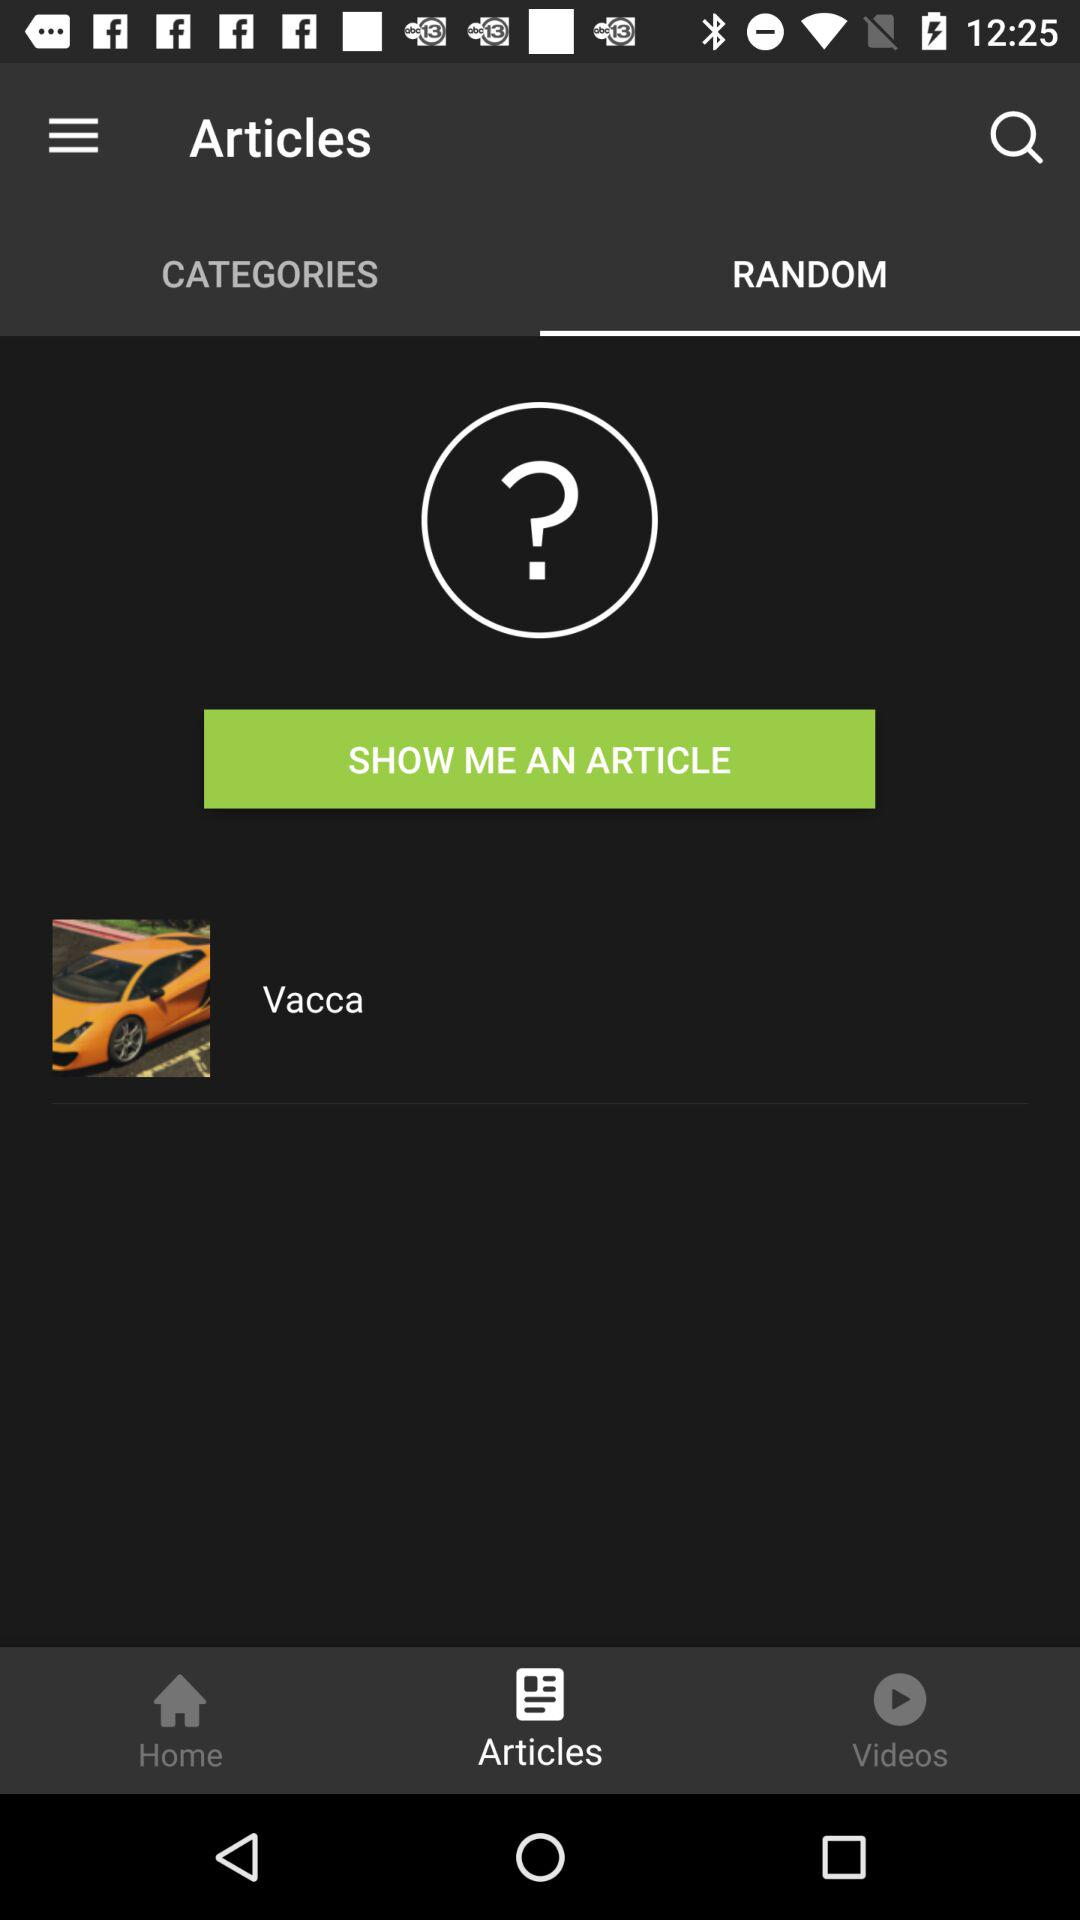What is the name of the article shown? The name of the article is Vacca. 